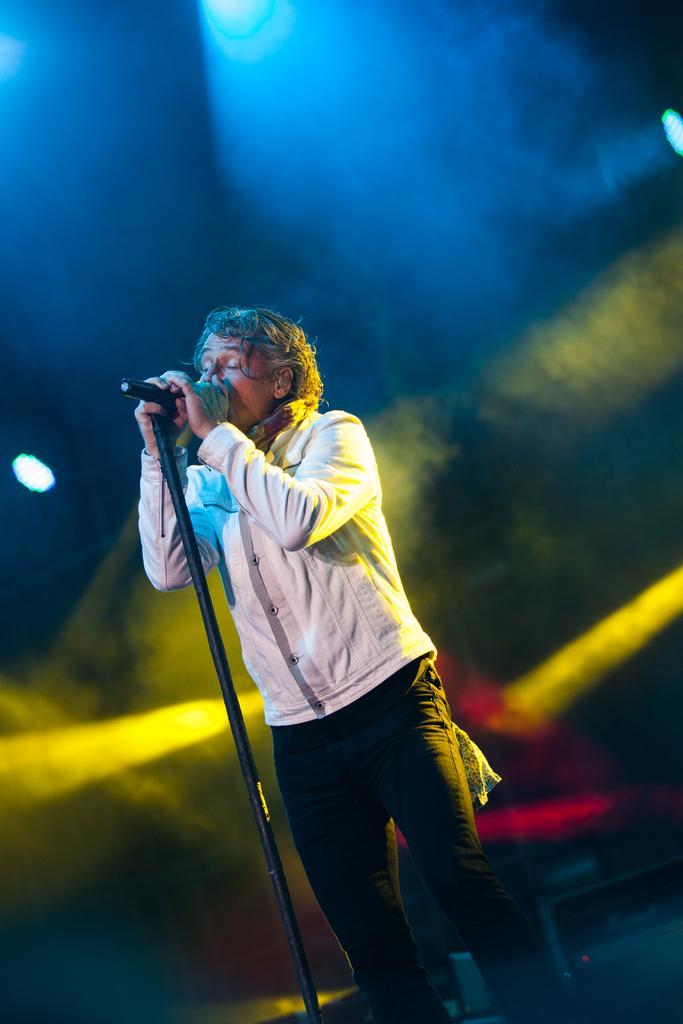In one or two sentences, can you explain what this image depicts? In the image we can see there is a person standing and he is holding mic. The mic is kept on the stand and behind there are lights. 